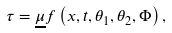<formula> <loc_0><loc_0><loc_500><loc_500>\tau = \underline { \mu } f \left ( x , t , \theta _ { 1 } , \theta _ { 2 } , \Phi \right ) ,</formula> 